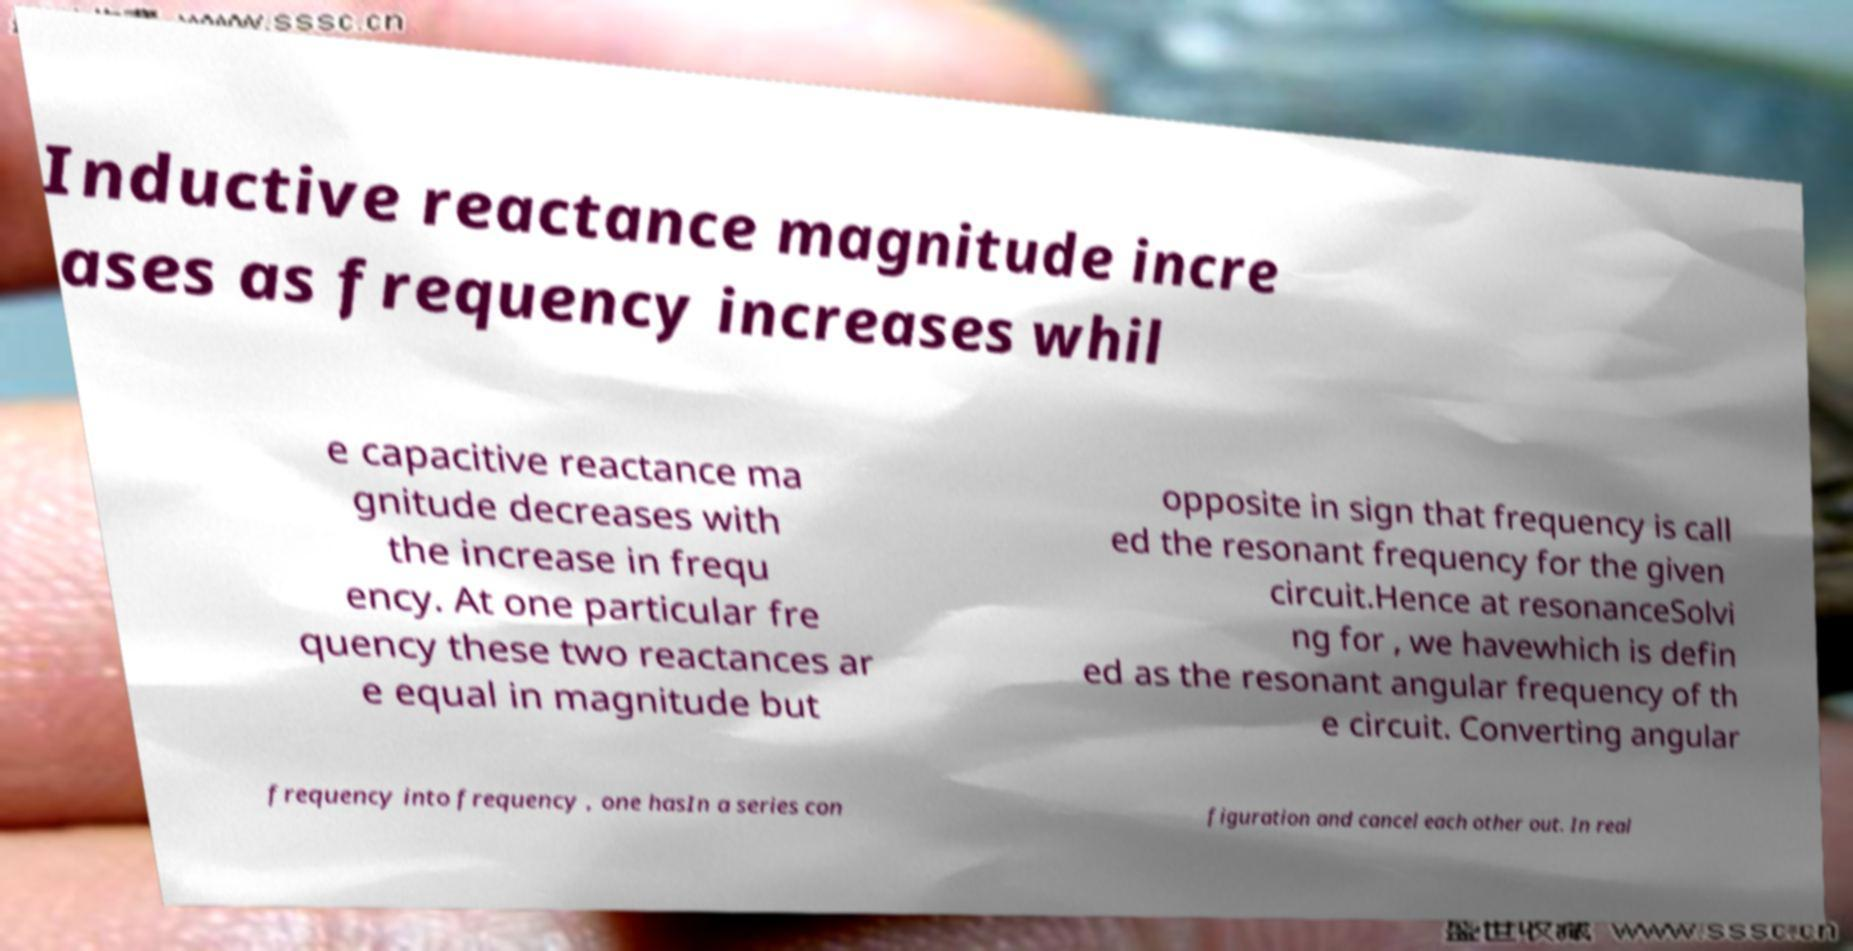Could you extract and type out the text from this image? Inductive reactance magnitude incre ases as frequency increases whil e capacitive reactance ma gnitude decreases with the increase in frequ ency. At one particular fre quency these two reactances ar e equal in magnitude but opposite in sign that frequency is call ed the resonant frequency for the given circuit.Hence at resonanceSolvi ng for , we havewhich is defin ed as the resonant angular frequency of th e circuit. Converting angular frequency into frequency , one hasIn a series con figuration and cancel each other out. In real 